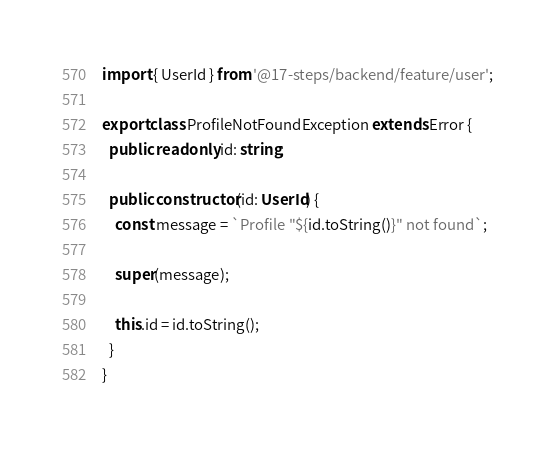<code> <loc_0><loc_0><loc_500><loc_500><_TypeScript_>import { UserId } from '@17-steps/backend/feature/user';

export class ProfileNotFoundException extends Error {
  public readonly id: string;

  public constructor(id: UserId) {
    const message = `Profile "${id.toString()}" not found`;

    super(message);

    this.id = id.toString();
  }
}
</code> 